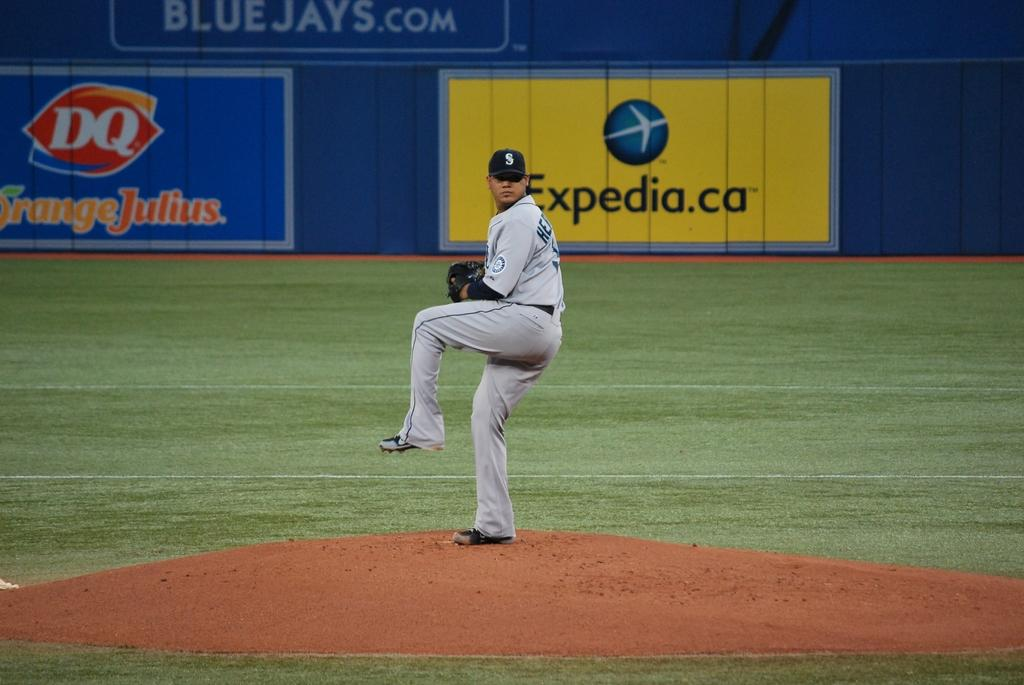<image>
Create a compact narrative representing the image presented. A pitcher winds up to pitch in front of an ad for Expedia. 